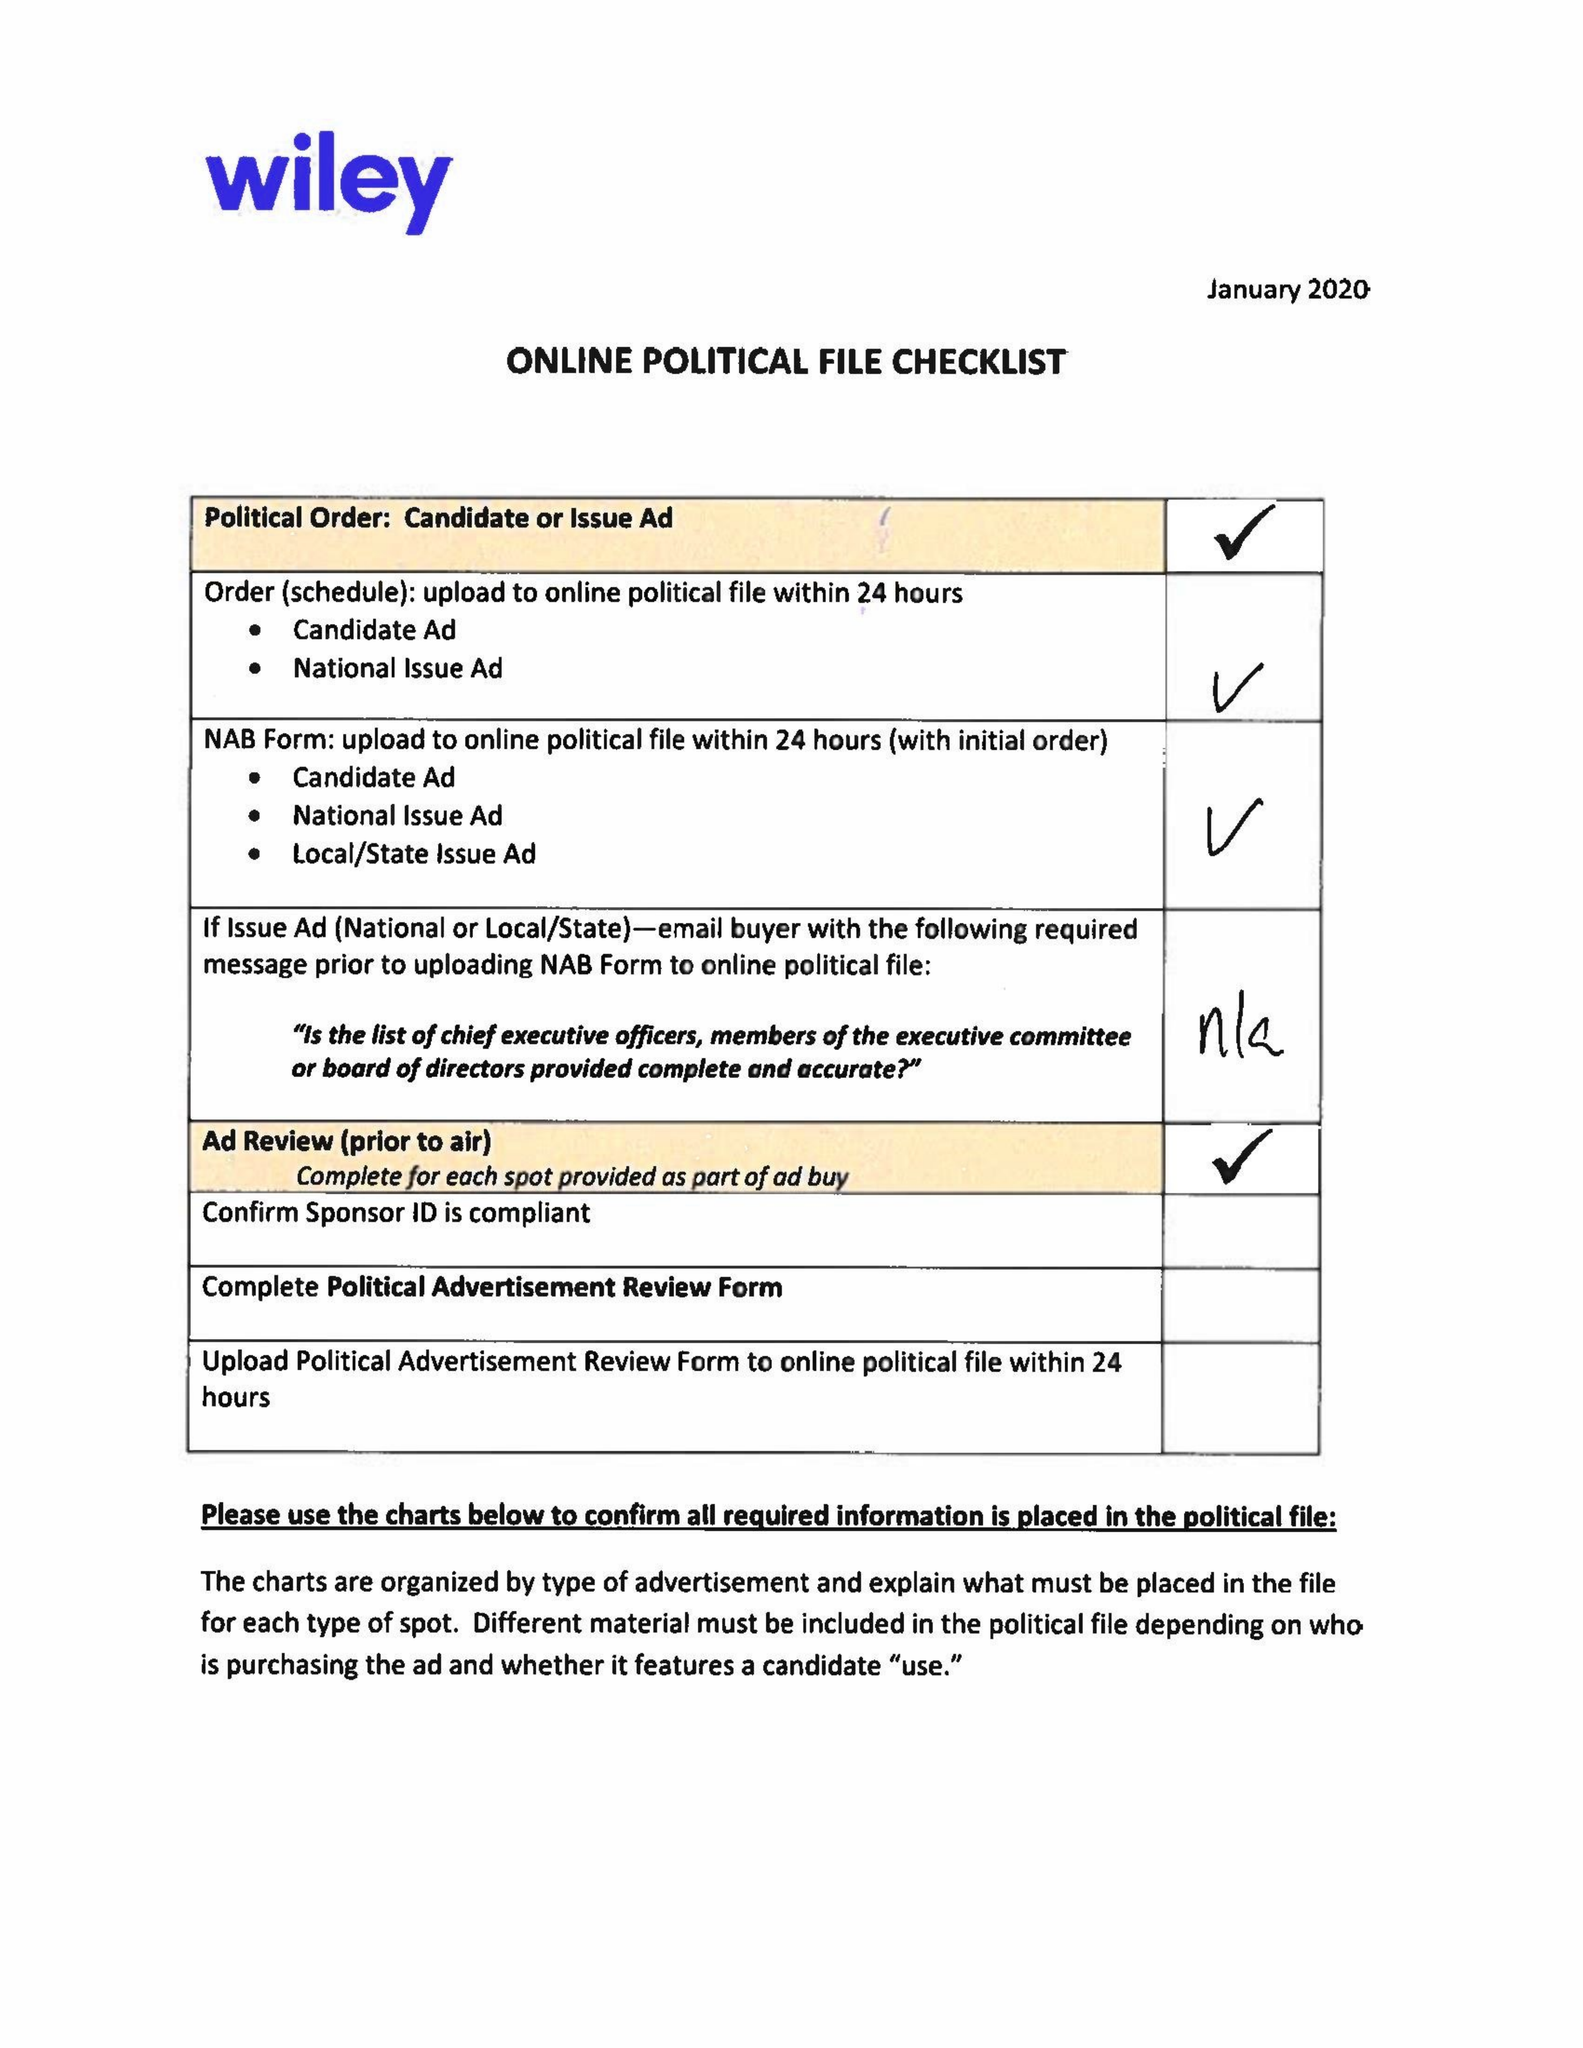What is the value for the contract_num?
Answer the question using a single word or phrase. 1522417 